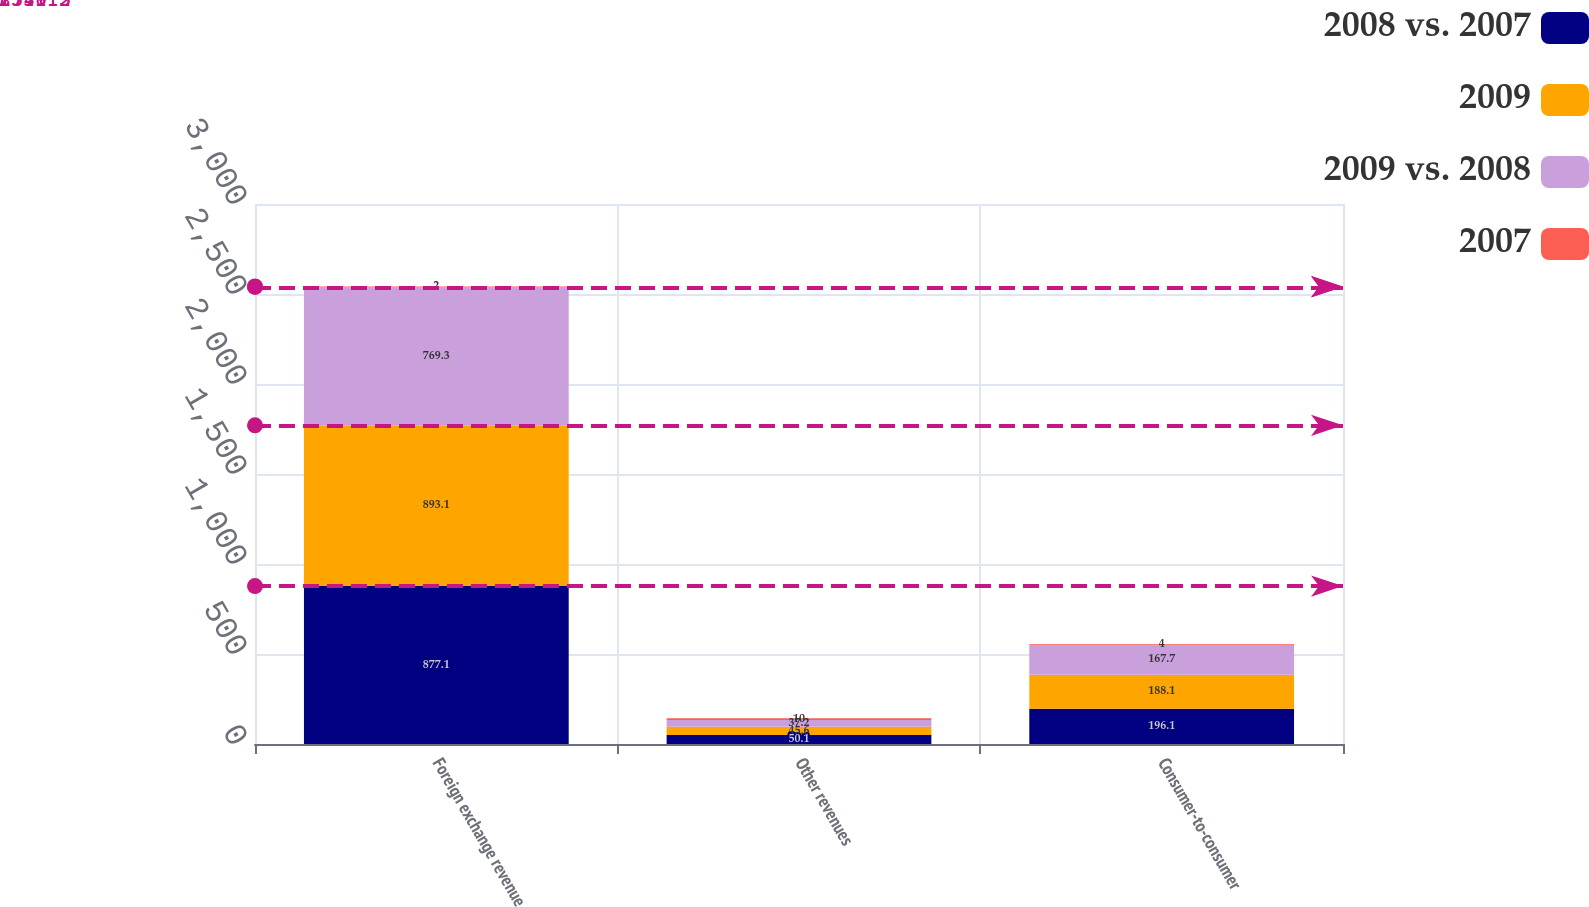Convert chart. <chart><loc_0><loc_0><loc_500><loc_500><stacked_bar_chart><ecel><fcel>Foreign exchange revenue<fcel>Other revenues<fcel>Consumer-to-consumer<nl><fcel>2008 vs. 2007<fcel>877.1<fcel>50.1<fcel>196.1<nl><fcel>2009<fcel>893.1<fcel>45.6<fcel>188.1<nl><fcel>2009 vs. 2008<fcel>769.3<fcel>37.2<fcel>167.7<nl><fcel>2007<fcel>2<fcel>10<fcel>4<nl></chart> 